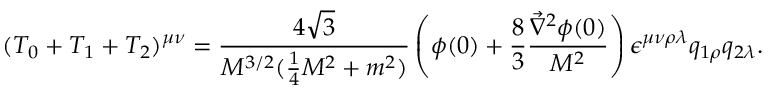<formula> <loc_0><loc_0><loc_500><loc_500>( T _ { 0 } + T _ { 1 } + T _ { 2 } ) ^ { \mu \nu } = \frac { 4 \sqrt { 3 } } { M ^ { 3 / 2 } ( \frac { 1 } { 4 } M ^ { 2 } + m ^ { 2 } ) } \left ( \phi ( 0 ) + \frac { 8 } { 3 } \frac { \vec { \nabla } ^ { 2 } \phi ( 0 ) } { M ^ { 2 } } \right ) \epsilon ^ { \mu \nu \rho \lambda } q _ { 1 \rho } q _ { 2 \lambda } .</formula> 